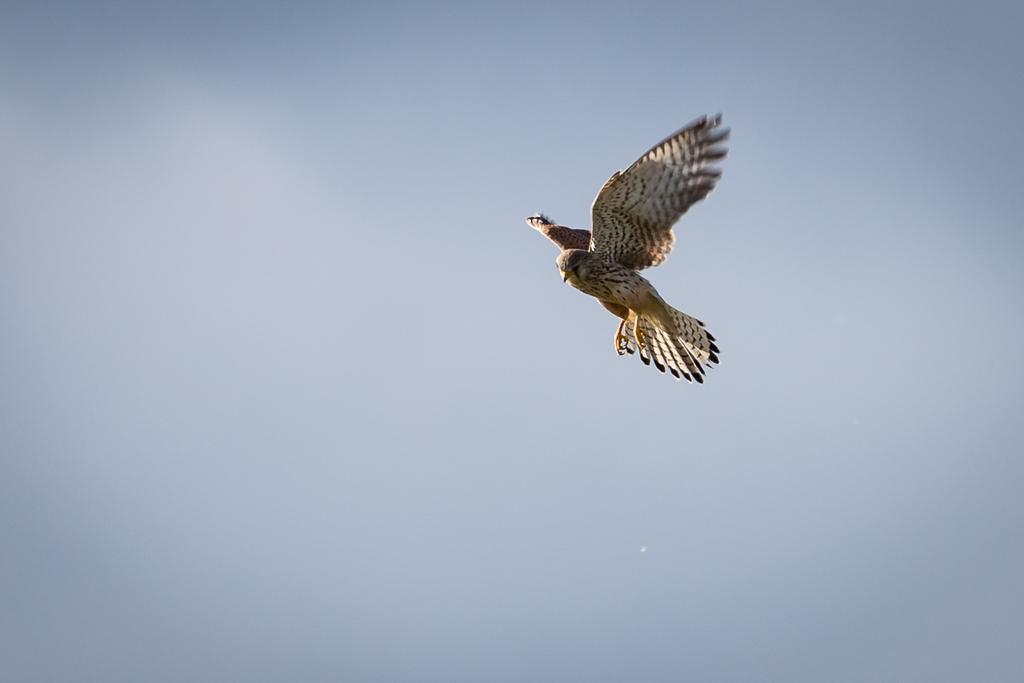Where was the picture taken? The picture was clicked outside the city. What can be seen in the sky on the right side of the image? There is a bird flying in the sky on the right side of the image. What is visible in the background of the image? The sky is visible in the background of the image. Where is the sofa placed in the image? There is no sofa present in the image. What type of pan is being used by the bird in the image? There is no pan or bird using a pan in the image. 